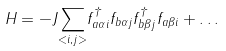<formula> <loc_0><loc_0><loc_500><loc_500>H = - J { \sum _ { < i , j > } } { f ^ { \dagger } _ { a \alpha i } } { f _ { b \alpha j } } { f ^ { \dagger } _ { b \beta j } } { f _ { a \beta i } } + \dots</formula> 